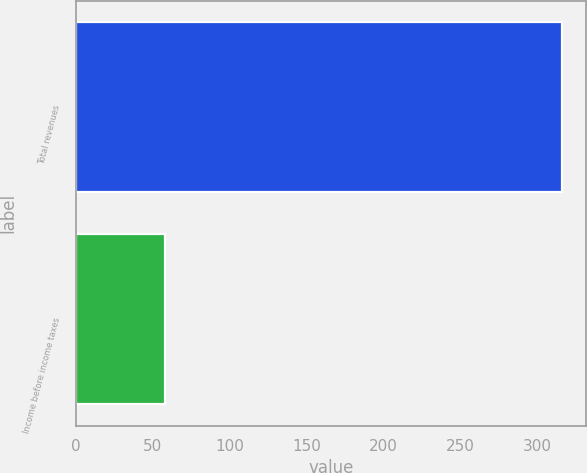Convert chart. <chart><loc_0><loc_0><loc_500><loc_500><bar_chart><fcel>Total revenues<fcel>Income before income taxes<nl><fcel>316<fcel>58<nl></chart> 